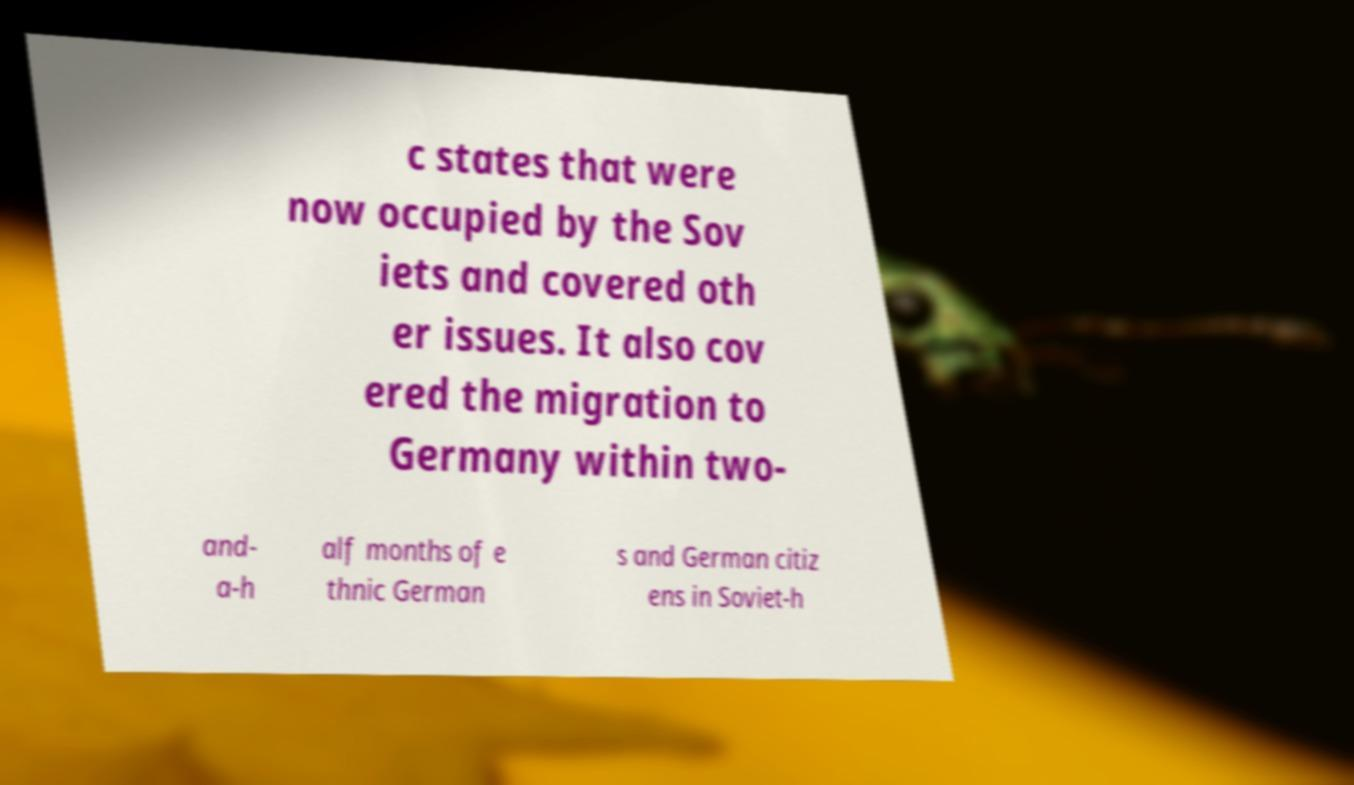For documentation purposes, I need the text within this image transcribed. Could you provide that? c states that were now occupied by the Sov iets and covered oth er issues. It also cov ered the migration to Germany within two- and- a-h alf months of e thnic German s and German citiz ens in Soviet-h 